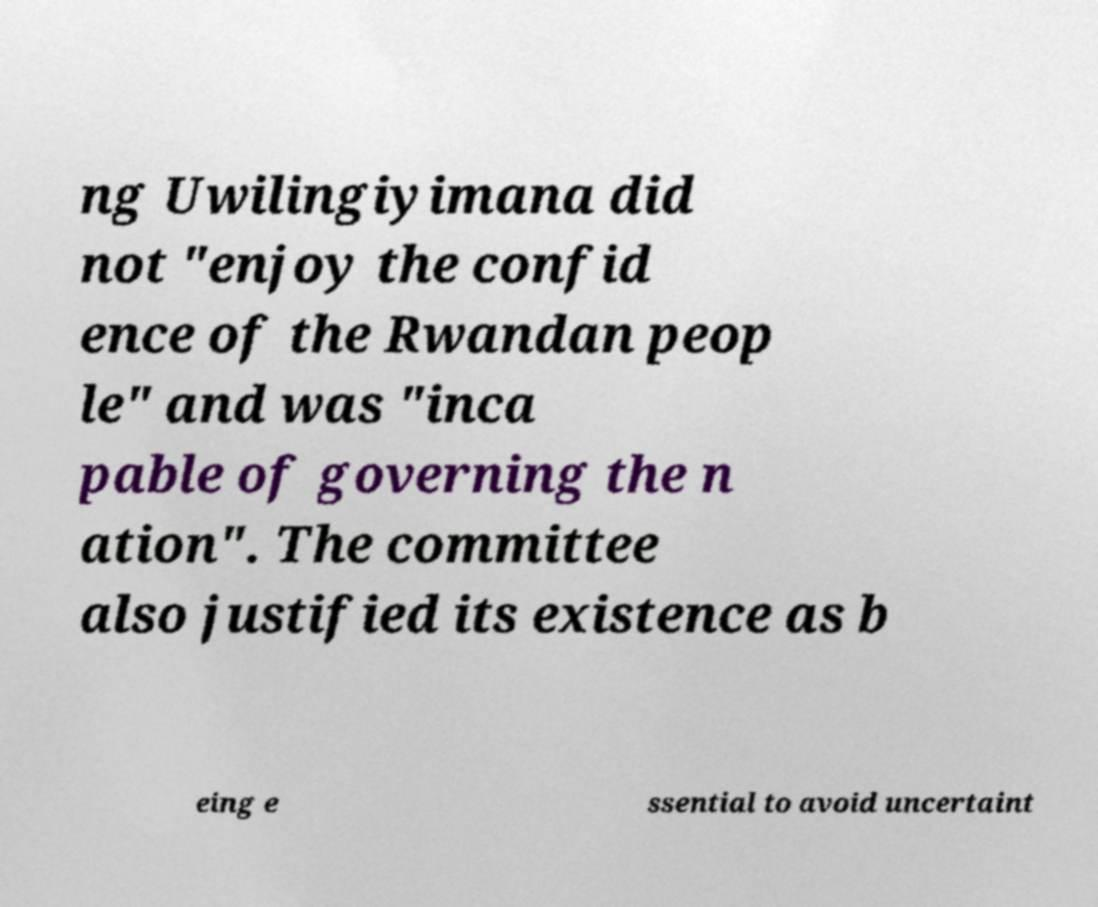For documentation purposes, I need the text within this image transcribed. Could you provide that? ng Uwilingiyimana did not "enjoy the confid ence of the Rwandan peop le" and was "inca pable of governing the n ation". The committee also justified its existence as b eing e ssential to avoid uncertaint 